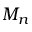<formula> <loc_0><loc_0><loc_500><loc_500>M _ { n }</formula> 